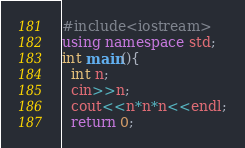<code> <loc_0><loc_0><loc_500><loc_500><_C++_>#include<iostream>
using namespace std;
int main(){
  int n;
  cin>>n;
  cout<<n*n*n<<endl;
  return 0;</code> 